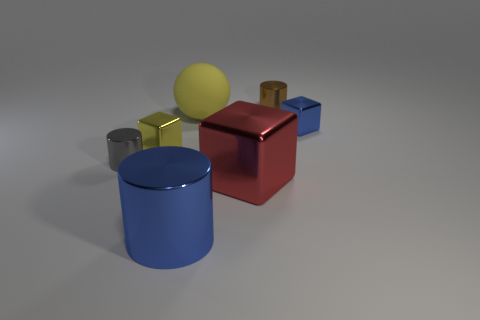Subtract 1 cubes. How many cubes are left? 2 Subtract all tiny shiny blocks. How many blocks are left? 1 Add 1 spheres. How many objects exist? 8 Subtract all cylinders. How many objects are left? 4 Subtract all purple cylinders. Subtract all cyan balls. How many cylinders are left? 3 Add 5 tiny yellow metal objects. How many tiny yellow metal objects are left? 6 Add 7 gray matte cubes. How many gray matte cubes exist? 7 Subtract 0 cyan spheres. How many objects are left? 7 Subtract all small cyan matte things. Subtract all brown cylinders. How many objects are left? 6 